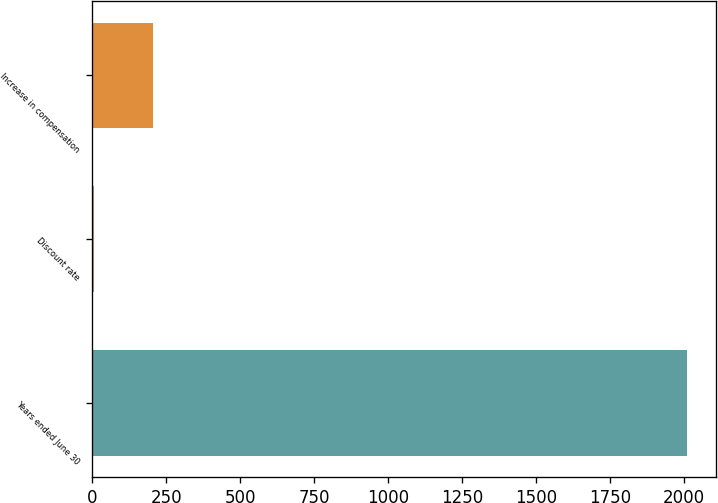Convert chart to OTSL. <chart><loc_0><loc_0><loc_500><loc_500><bar_chart><fcel>Years ended June 30<fcel>Discount rate<fcel>Increase in compensation<nl><fcel>2010<fcel>5.25<fcel>205.73<nl></chart> 